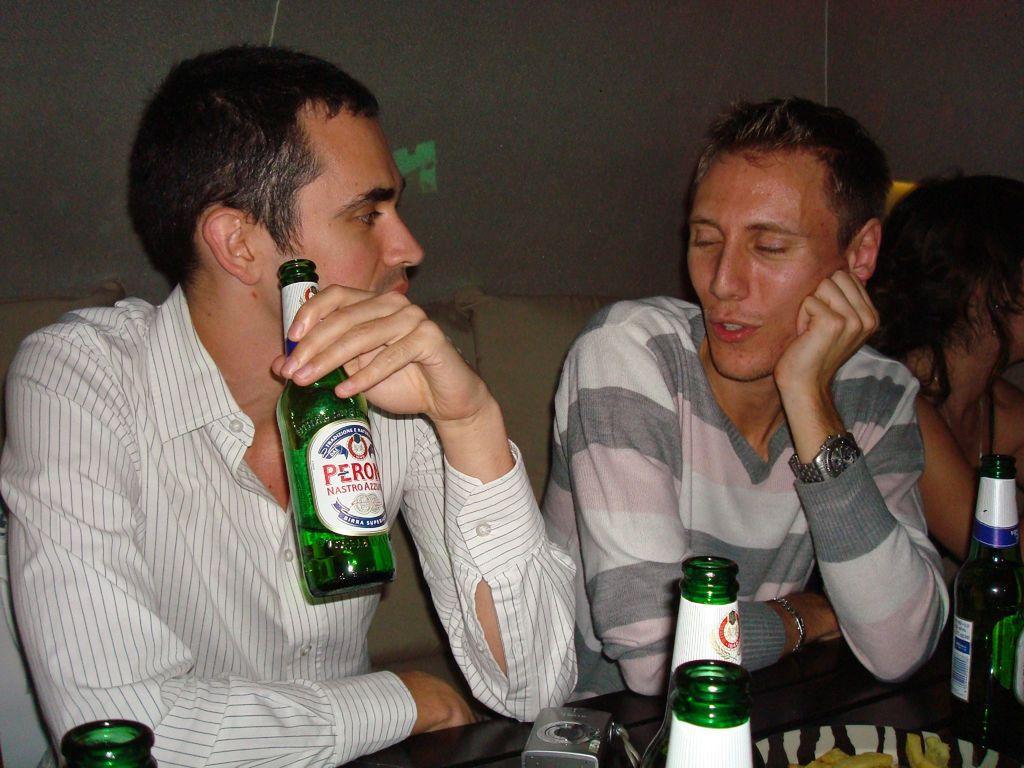How would you summarize this image in a sentence or two? A person wearing a white shirt is holding a green bottle with a label. Another person sitting next to him wearing a watch and talking. In the front there is a table. On the table there are bottles, camera. In the back there's a wall. 